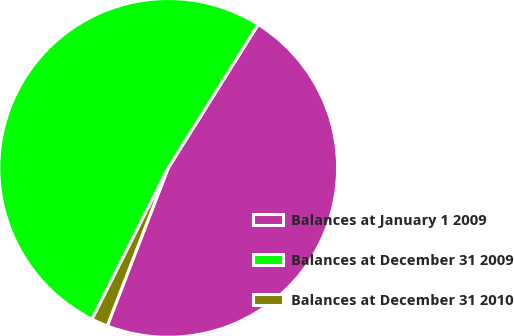Convert chart. <chart><loc_0><loc_0><loc_500><loc_500><pie_chart><fcel>Balances at January 1 2009<fcel>Balances at December 31 2009<fcel>Balances at December 31 2010<nl><fcel>46.95%<fcel>51.49%<fcel>1.56%<nl></chart> 